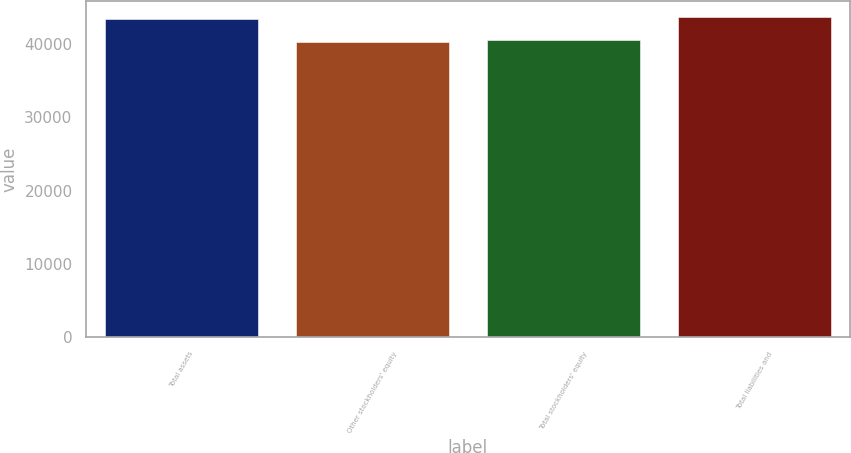Convert chart. <chart><loc_0><loc_0><loc_500><loc_500><bar_chart><fcel>Total assets<fcel>Other stockholders' equity<fcel>Total stockholders' equity<fcel>Total liabilities and<nl><fcel>43356<fcel>40240<fcel>40551.6<fcel>43667.6<nl></chart> 